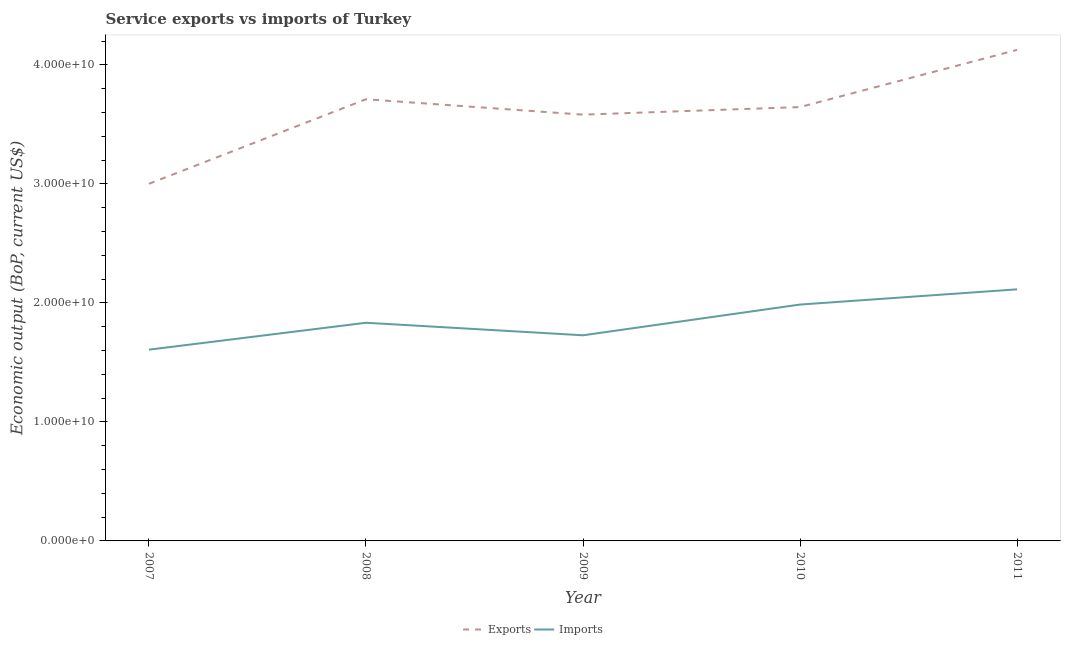How many different coloured lines are there?
Ensure brevity in your answer.  2. Is the number of lines equal to the number of legend labels?
Keep it short and to the point. Yes. What is the amount of service imports in 2007?
Your answer should be very brief. 1.61e+1. Across all years, what is the maximum amount of service imports?
Offer a very short reply. 2.11e+1. Across all years, what is the minimum amount of service exports?
Provide a succinct answer. 3.00e+1. What is the total amount of service exports in the graph?
Ensure brevity in your answer.  1.81e+11. What is the difference between the amount of service exports in 2007 and that in 2009?
Ensure brevity in your answer.  -5.81e+09. What is the difference between the amount of service exports in 2010 and the amount of service imports in 2008?
Your answer should be very brief. 1.81e+1. What is the average amount of service exports per year?
Offer a terse response. 3.61e+1. In the year 2011, what is the difference between the amount of service imports and amount of service exports?
Provide a succinct answer. -2.01e+1. In how many years, is the amount of service exports greater than 38000000000 US$?
Keep it short and to the point. 1. What is the ratio of the amount of service imports in 2008 to that in 2011?
Your response must be concise. 0.87. Is the amount of service exports in 2010 less than that in 2011?
Provide a succinct answer. Yes. What is the difference between the highest and the second highest amount of service exports?
Provide a short and direct response. 4.15e+09. What is the difference between the highest and the lowest amount of service exports?
Give a very brief answer. 1.13e+1. In how many years, is the amount of service exports greater than the average amount of service exports taken over all years?
Your answer should be very brief. 3. Does the amount of service exports monotonically increase over the years?
Offer a very short reply. No. Is the amount of service imports strictly greater than the amount of service exports over the years?
Give a very brief answer. No. How many lines are there?
Give a very brief answer. 2. Are the values on the major ticks of Y-axis written in scientific E-notation?
Offer a terse response. Yes. Does the graph contain any zero values?
Give a very brief answer. No. Does the graph contain grids?
Keep it short and to the point. No. How many legend labels are there?
Provide a succinct answer. 2. How are the legend labels stacked?
Your answer should be very brief. Horizontal. What is the title of the graph?
Your answer should be very brief. Service exports vs imports of Turkey. Does "% of gross capital formation" appear as one of the legend labels in the graph?
Provide a short and direct response. No. What is the label or title of the Y-axis?
Offer a very short reply. Economic output (BoP, current US$). What is the Economic output (BoP, current US$) of Exports in 2007?
Give a very brief answer. 3.00e+1. What is the Economic output (BoP, current US$) of Imports in 2007?
Make the answer very short. 1.61e+1. What is the Economic output (BoP, current US$) of Exports in 2008?
Your answer should be very brief. 3.71e+1. What is the Economic output (BoP, current US$) of Imports in 2008?
Your answer should be very brief. 1.83e+1. What is the Economic output (BoP, current US$) of Exports in 2009?
Your response must be concise. 3.58e+1. What is the Economic output (BoP, current US$) in Imports in 2009?
Ensure brevity in your answer.  1.73e+1. What is the Economic output (BoP, current US$) of Exports in 2010?
Ensure brevity in your answer.  3.65e+1. What is the Economic output (BoP, current US$) of Imports in 2010?
Make the answer very short. 1.99e+1. What is the Economic output (BoP, current US$) in Exports in 2011?
Give a very brief answer. 4.13e+1. What is the Economic output (BoP, current US$) in Imports in 2011?
Give a very brief answer. 2.11e+1. Across all years, what is the maximum Economic output (BoP, current US$) in Exports?
Give a very brief answer. 4.13e+1. Across all years, what is the maximum Economic output (BoP, current US$) of Imports?
Your answer should be compact. 2.11e+1. Across all years, what is the minimum Economic output (BoP, current US$) of Exports?
Offer a very short reply. 3.00e+1. Across all years, what is the minimum Economic output (BoP, current US$) of Imports?
Your answer should be very brief. 1.61e+1. What is the total Economic output (BoP, current US$) of Exports in the graph?
Provide a short and direct response. 1.81e+11. What is the total Economic output (BoP, current US$) in Imports in the graph?
Give a very brief answer. 9.27e+1. What is the difference between the Economic output (BoP, current US$) in Exports in 2007 and that in 2008?
Provide a short and direct response. -7.10e+09. What is the difference between the Economic output (BoP, current US$) of Imports in 2007 and that in 2008?
Ensure brevity in your answer.  -2.26e+09. What is the difference between the Economic output (BoP, current US$) in Exports in 2007 and that in 2009?
Offer a very short reply. -5.81e+09. What is the difference between the Economic output (BoP, current US$) of Imports in 2007 and that in 2009?
Offer a very short reply. -1.21e+09. What is the difference between the Economic output (BoP, current US$) of Exports in 2007 and that in 2010?
Your answer should be compact. -6.45e+09. What is the difference between the Economic output (BoP, current US$) in Imports in 2007 and that in 2010?
Make the answer very short. -3.79e+09. What is the difference between the Economic output (BoP, current US$) of Exports in 2007 and that in 2011?
Your answer should be compact. -1.13e+1. What is the difference between the Economic output (BoP, current US$) of Imports in 2007 and that in 2011?
Give a very brief answer. -5.07e+09. What is the difference between the Economic output (BoP, current US$) in Exports in 2008 and that in 2009?
Your answer should be very brief. 1.29e+09. What is the difference between the Economic output (BoP, current US$) in Imports in 2008 and that in 2009?
Provide a short and direct response. 1.05e+09. What is the difference between the Economic output (BoP, current US$) of Exports in 2008 and that in 2010?
Offer a terse response. 6.56e+08. What is the difference between the Economic output (BoP, current US$) of Imports in 2008 and that in 2010?
Ensure brevity in your answer.  -1.53e+09. What is the difference between the Economic output (BoP, current US$) in Exports in 2008 and that in 2011?
Offer a terse response. -4.15e+09. What is the difference between the Economic output (BoP, current US$) in Imports in 2008 and that in 2011?
Make the answer very short. -2.81e+09. What is the difference between the Economic output (BoP, current US$) of Exports in 2009 and that in 2010?
Provide a short and direct response. -6.38e+08. What is the difference between the Economic output (BoP, current US$) of Imports in 2009 and that in 2010?
Provide a short and direct response. -2.58e+09. What is the difference between the Economic output (BoP, current US$) of Exports in 2009 and that in 2011?
Your response must be concise. -5.44e+09. What is the difference between the Economic output (BoP, current US$) of Imports in 2009 and that in 2011?
Make the answer very short. -3.86e+09. What is the difference between the Economic output (BoP, current US$) in Exports in 2010 and that in 2011?
Give a very brief answer. -4.80e+09. What is the difference between the Economic output (BoP, current US$) of Imports in 2010 and that in 2011?
Provide a succinct answer. -1.28e+09. What is the difference between the Economic output (BoP, current US$) of Exports in 2007 and the Economic output (BoP, current US$) of Imports in 2008?
Make the answer very short. 1.17e+1. What is the difference between the Economic output (BoP, current US$) in Exports in 2007 and the Economic output (BoP, current US$) in Imports in 2009?
Make the answer very short. 1.27e+1. What is the difference between the Economic output (BoP, current US$) of Exports in 2007 and the Economic output (BoP, current US$) of Imports in 2010?
Provide a succinct answer. 1.01e+1. What is the difference between the Economic output (BoP, current US$) in Exports in 2007 and the Economic output (BoP, current US$) in Imports in 2011?
Make the answer very short. 8.87e+09. What is the difference between the Economic output (BoP, current US$) of Exports in 2008 and the Economic output (BoP, current US$) of Imports in 2009?
Keep it short and to the point. 1.98e+1. What is the difference between the Economic output (BoP, current US$) in Exports in 2008 and the Economic output (BoP, current US$) in Imports in 2010?
Ensure brevity in your answer.  1.72e+1. What is the difference between the Economic output (BoP, current US$) in Exports in 2008 and the Economic output (BoP, current US$) in Imports in 2011?
Offer a terse response. 1.60e+1. What is the difference between the Economic output (BoP, current US$) in Exports in 2009 and the Economic output (BoP, current US$) in Imports in 2010?
Ensure brevity in your answer.  1.60e+1. What is the difference between the Economic output (BoP, current US$) of Exports in 2009 and the Economic output (BoP, current US$) of Imports in 2011?
Offer a terse response. 1.47e+1. What is the difference between the Economic output (BoP, current US$) in Exports in 2010 and the Economic output (BoP, current US$) in Imports in 2011?
Ensure brevity in your answer.  1.53e+1. What is the average Economic output (BoP, current US$) of Exports per year?
Ensure brevity in your answer.  3.61e+1. What is the average Economic output (BoP, current US$) of Imports per year?
Keep it short and to the point. 1.85e+1. In the year 2007, what is the difference between the Economic output (BoP, current US$) in Exports and Economic output (BoP, current US$) in Imports?
Your answer should be very brief. 1.39e+1. In the year 2008, what is the difference between the Economic output (BoP, current US$) of Exports and Economic output (BoP, current US$) of Imports?
Your response must be concise. 1.88e+1. In the year 2009, what is the difference between the Economic output (BoP, current US$) in Exports and Economic output (BoP, current US$) in Imports?
Provide a succinct answer. 1.85e+1. In the year 2010, what is the difference between the Economic output (BoP, current US$) of Exports and Economic output (BoP, current US$) of Imports?
Ensure brevity in your answer.  1.66e+1. In the year 2011, what is the difference between the Economic output (BoP, current US$) in Exports and Economic output (BoP, current US$) in Imports?
Provide a short and direct response. 2.01e+1. What is the ratio of the Economic output (BoP, current US$) in Exports in 2007 to that in 2008?
Make the answer very short. 0.81. What is the ratio of the Economic output (BoP, current US$) in Imports in 2007 to that in 2008?
Your response must be concise. 0.88. What is the ratio of the Economic output (BoP, current US$) of Exports in 2007 to that in 2009?
Your response must be concise. 0.84. What is the ratio of the Economic output (BoP, current US$) in Imports in 2007 to that in 2009?
Make the answer very short. 0.93. What is the ratio of the Economic output (BoP, current US$) in Exports in 2007 to that in 2010?
Ensure brevity in your answer.  0.82. What is the ratio of the Economic output (BoP, current US$) in Imports in 2007 to that in 2010?
Ensure brevity in your answer.  0.81. What is the ratio of the Economic output (BoP, current US$) of Exports in 2007 to that in 2011?
Your response must be concise. 0.73. What is the ratio of the Economic output (BoP, current US$) in Imports in 2007 to that in 2011?
Keep it short and to the point. 0.76. What is the ratio of the Economic output (BoP, current US$) in Exports in 2008 to that in 2009?
Provide a succinct answer. 1.04. What is the ratio of the Economic output (BoP, current US$) of Imports in 2008 to that in 2009?
Offer a very short reply. 1.06. What is the ratio of the Economic output (BoP, current US$) of Exports in 2008 to that in 2010?
Give a very brief answer. 1.02. What is the ratio of the Economic output (BoP, current US$) of Imports in 2008 to that in 2010?
Ensure brevity in your answer.  0.92. What is the ratio of the Economic output (BoP, current US$) of Exports in 2008 to that in 2011?
Your answer should be very brief. 0.9. What is the ratio of the Economic output (BoP, current US$) of Imports in 2008 to that in 2011?
Ensure brevity in your answer.  0.87. What is the ratio of the Economic output (BoP, current US$) in Exports in 2009 to that in 2010?
Keep it short and to the point. 0.98. What is the ratio of the Economic output (BoP, current US$) of Imports in 2009 to that in 2010?
Offer a very short reply. 0.87. What is the ratio of the Economic output (BoP, current US$) of Exports in 2009 to that in 2011?
Your answer should be compact. 0.87. What is the ratio of the Economic output (BoP, current US$) in Imports in 2009 to that in 2011?
Provide a succinct answer. 0.82. What is the ratio of the Economic output (BoP, current US$) of Exports in 2010 to that in 2011?
Provide a succinct answer. 0.88. What is the ratio of the Economic output (BoP, current US$) of Imports in 2010 to that in 2011?
Provide a short and direct response. 0.94. What is the difference between the highest and the second highest Economic output (BoP, current US$) of Exports?
Make the answer very short. 4.15e+09. What is the difference between the highest and the second highest Economic output (BoP, current US$) in Imports?
Make the answer very short. 1.28e+09. What is the difference between the highest and the lowest Economic output (BoP, current US$) of Exports?
Your response must be concise. 1.13e+1. What is the difference between the highest and the lowest Economic output (BoP, current US$) of Imports?
Your response must be concise. 5.07e+09. 